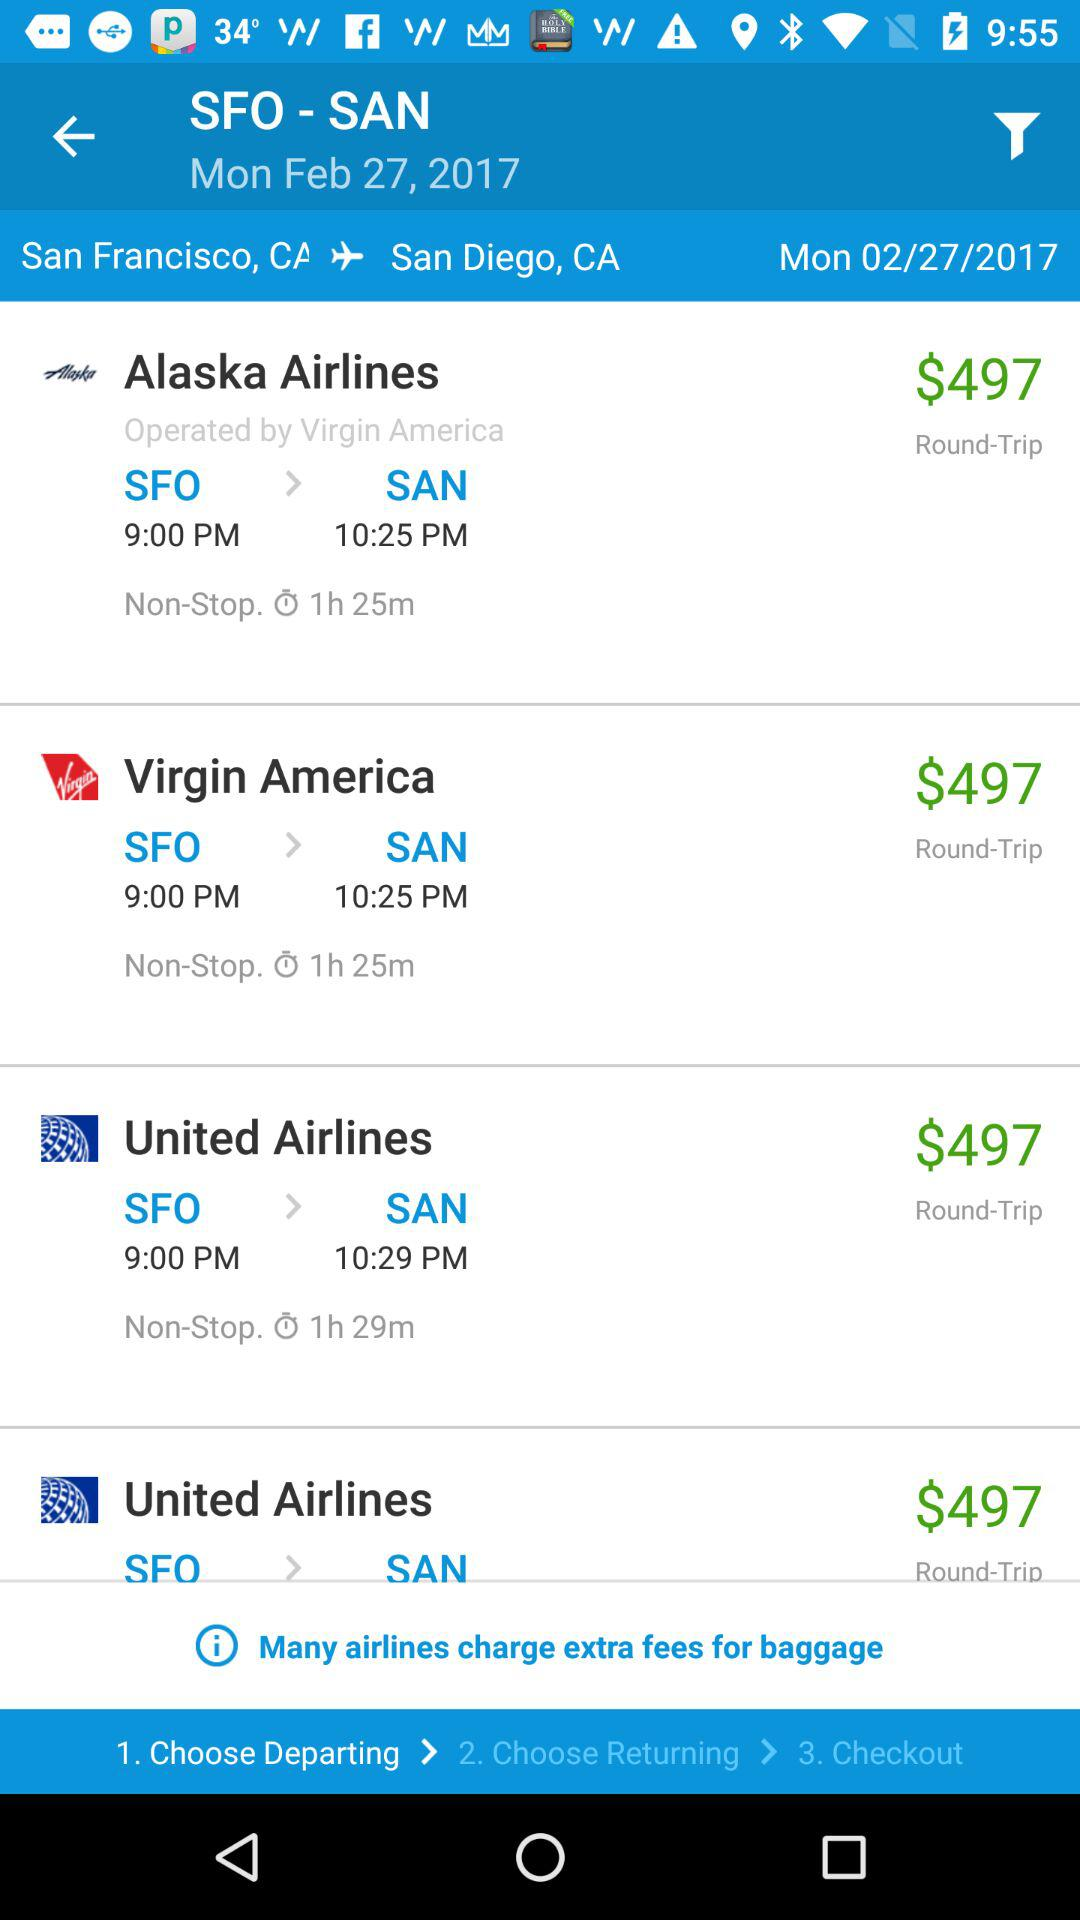What is the destination station? The destination station is San Diego, CA. 